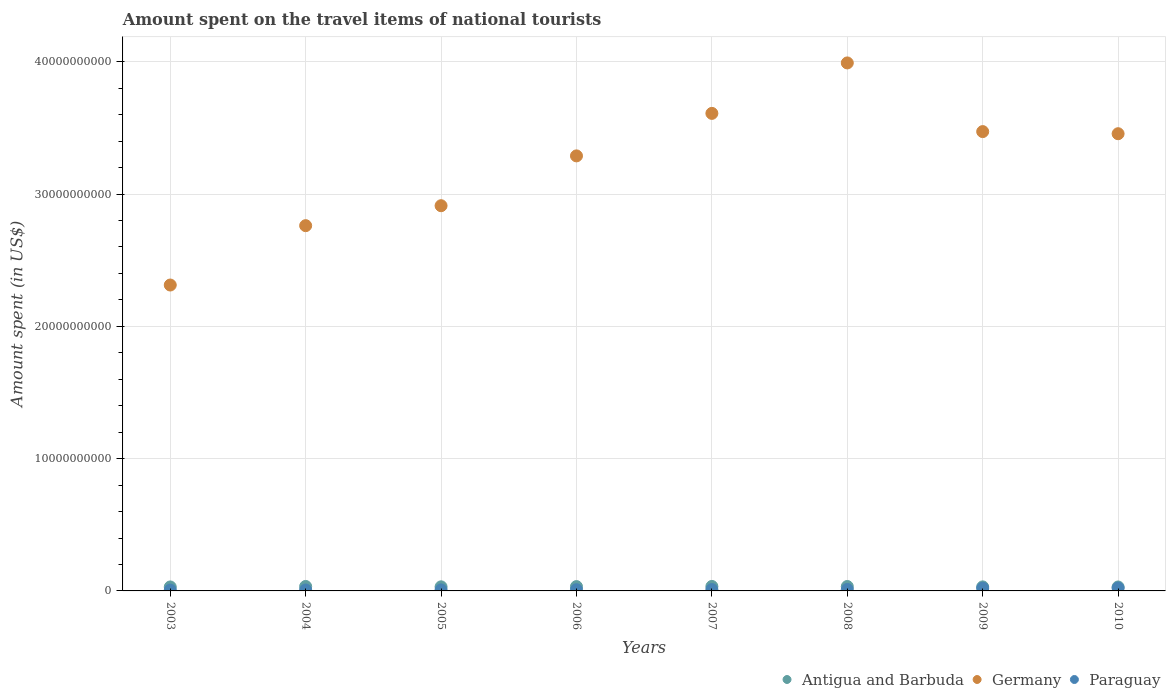Is the number of dotlines equal to the number of legend labels?
Keep it short and to the point. Yes. What is the amount spent on the travel items of national tourists in Paraguay in 2004?
Provide a short and direct response. 7.00e+07. Across all years, what is the maximum amount spent on the travel items of national tourists in Antigua and Barbuda?
Offer a very short reply. 3.38e+08. Across all years, what is the minimum amount spent on the travel items of national tourists in Paraguay?
Give a very brief answer. 6.40e+07. In which year was the amount spent on the travel items of national tourists in Paraguay maximum?
Offer a terse response. 2010. In which year was the amount spent on the travel items of national tourists in Paraguay minimum?
Your response must be concise. 2003. What is the total amount spent on the travel items of national tourists in Germany in the graph?
Provide a succinct answer. 2.58e+11. What is the difference between the amount spent on the travel items of national tourists in Germany in 2005 and that in 2008?
Your answer should be very brief. -1.08e+1. What is the difference between the amount spent on the travel items of national tourists in Germany in 2004 and the amount spent on the travel items of national tourists in Paraguay in 2010?
Provide a short and direct response. 2.74e+1. What is the average amount spent on the travel items of national tourists in Germany per year?
Offer a very short reply. 3.23e+1. In the year 2005, what is the difference between the amount spent on the travel items of national tourists in Antigua and Barbuda and amount spent on the travel items of national tourists in Germany?
Your response must be concise. -2.88e+1. What is the ratio of the amount spent on the travel items of national tourists in Germany in 2006 to that in 2010?
Give a very brief answer. 0.95. Is the difference between the amount spent on the travel items of national tourists in Antigua and Barbuda in 2003 and 2009 greater than the difference between the amount spent on the travel items of national tourists in Germany in 2003 and 2009?
Your response must be concise. Yes. What is the difference between the highest and the second highest amount spent on the travel items of national tourists in Antigua and Barbuda?
Provide a short and direct response. 1.00e+06. What is the difference between the highest and the lowest amount spent on the travel items of national tourists in Antigua and Barbuda?
Offer a very short reply. 4.00e+07. In how many years, is the amount spent on the travel items of national tourists in Paraguay greater than the average amount spent on the travel items of national tourists in Paraguay taken over all years?
Your answer should be compact. 2. Is the sum of the amount spent on the travel items of national tourists in Germany in 2006 and 2010 greater than the maximum amount spent on the travel items of national tourists in Paraguay across all years?
Your answer should be compact. Yes. Does the amount spent on the travel items of national tourists in Germany monotonically increase over the years?
Offer a terse response. No. Is the amount spent on the travel items of national tourists in Paraguay strictly less than the amount spent on the travel items of national tourists in Germany over the years?
Provide a short and direct response. Yes. How many dotlines are there?
Your answer should be very brief. 3. What is the difference between two consecutive major ticks on the Y-axis?
Keep it short and to the point. 1.00e+1. Are the values on the major ticks of Y-axis written in scientific E-notation?
Give a very brief answer. No. Does the graph contain grids?
Give a very brief answer. Yes. Where does the legend appear in the graph?
Give a very brief answer. Bottom right. What is the title of the graph?
Offer a very short reply. Amount spent on the travel items of national tourists. What is the label or title of the Y-axis?
Offer a terse response. Amount spent (in US$). What is the Amount spent (in US$) in Antigua and Barbuda in 2003?
Keep it short and to the point. 3.00e+08. What is the Amount spent (in US$) of Germany in 2003?
Provide a short and direct response. 2.31e+1. What is the Amount spent (in US$) of Paraguay in 2003?
Offer a very short reply. 6.40e+07. What is the Amount spent (in US$) in Antigua and Barbuda in 2004?
Your answer should be compact. 3.37e+08. What is the Amount spent (in US$) in Germany in 2004?
Give a very brief answer. 2.76e+1. What is the Amount spent (in US$) of Paraguay in 2004?
Provide a succinct answer. 7.00e+07. What is the Amount spent (in US$) in Antigua and Barbuda in 2005?
Provide a short and direct response. 3.09e+08. What is the Amount spent (in US$) of Germany in 2005?
Keep it short and to the point. 2.91e+1. What is the Amount spent (in US$) of Paraguay in 2005?
Provide a succinct answer. 7.80e+07. What is the Amount spent (in US$) of Antigua and Barbuda in 2006?
Provide a short and direct response. 3.27e+08. What is the Amount spent (in US$) of Germany in 2006?
Your answer should be compact. 3.29e+1. What is the Amount spent (in US$) of Paraguay in 2006?
Your answer should be very brief. 9.20e+07. What is the Amount spent (in US$) in Antigua and Barbuda in 2007?
Your answer should be very brief. 3.38e+08. What is the Amount spent (in US$) of Germany in 2007?
Offer a very short reply. 3.61e+1. What is the Amount spent (in US$) of Paraguay in 2007?
Keep it short and to the point. 1.02e+08. What is the Amount spent (in US$) of Antigua and Barbuda in 2008?
Offer a terse response. 3.34e+08. What is the Amount spent (in US$) of Germany in 2008?
Your response must be concise. 3.99e+1. What is the Amount spent (in US$) of Paraguay in 2008?
Give a very brief answer. 1.09e+08. What is the Amount spent (in US$) in Antigua and Barbuda in 2009?
Provide a succinct answer. 3.05e+08. What is the Amount spent (in US$) in Germany in 2009?
Provide a succinct answer. 3.47e+1. What is the Amount spent (in US$) in Paraguay in 2009?
Offer a terse response. 2.05e+08. What is the Amount spent (in US$) of Antigua and Barbuda in 2010?
Provide a succinct answer. 2.98e+08. What is the Amount spent (in US$) of Germany in 2010?
Keep it short and to the point. 3.46e+1. What is the Amount spent (in US$) of Paraguay in 2010?
Provide a short and direct response. 2.17e+08. Across all years, what is the maximum Amount spent (in US$) of Antigua and Barbuda?
Provide a succinct answer. 3.38e+08. Across all years, what is the maximum Amount spent (in US$) in Germany?
Your response must be concise. 3.99e+1. Across all years, what is the maximum Amount spent (in US$) of Paraguay?
Offer a terse response. 2.17e+08. Across all years, what is the minimum Amount spent (in US$) in Antigua and Barbuda?
Ensure brevity in your answer.  2.98e+08. Across all years, what is the minimum Amount spent (in US$) of Germany?
Give a very brief answer. 2.31e+1. Across all years, what is the minimum Amount spent (in US$) in Paraguay?
Your answer should be very brief. 6.40e+07. What is the total Amount spent (in US$) in Antigua and Barbuda in the graph?
Offer a terse response. 2.55e+09. What is the total Amount spent (in US$) of Germany in the graph?
Ensure brevity in your answer.  2.58e+11. What is the total Amount spent (in US$) in Paraguay in the graph?
Offer a terse response. 9.37e+08. What is the difference between the Amount spent (in US$) in Antigua and Barbuda in 2003 and that in 2004?
Offer a very short reply. -3.70e+07. What is the difference between the Amount spent (in US$) in Germany in 2003 and that in 2004?
Keep it short and to the point. -4.49e+09. What is the difference between the Amount spent (in US$) of Paraguay in 2003 and that in 2004?
Your answer should be compact. -6.00e+06. What is the difference between the Amount spent (in US$) of Antigua and Barbuda in 2003 and that in 2005?
Your response must be concise. -9.00e+06. What is the difference between the Amount spent (in US$) in Germany in 2003 and that in 2005?
Provide a short and direct response. -6.00e+09. What is the difference between the Amount spent (in US$) of Paraguay in 2003 and that in 2005?
Your answer should be very brief. -1.40e+07. What is the difference between the Amount spent (in US$) of Antigua and Barbuda in 2003 and that in 2006?
Keep it short and to the point. -2.70e+07. What is the difference between the Amount spent (in US$) in Germany in 2003 and that in 2006?
Give a very brief answer. -9.76e+09. What is the difference between the Amount spent (in US$) in Paraguay in 2003 and that in 2006?
Offer a terse response. -2.80e+07. What is the difference between the Amount spent (in US$) of Antigua and Barbuda in 2003 and that in 2007?
Provide a short and direct response. -3.80e+07. What is the difference between the Amount spent (in US$) in Germany in 2003 and that in 2007?
Ensure brevity in your answer.  -1.30e+1. What is the difference between the Amount spent (in US$) in Paraguay in 2003 and that in 2007?
Your answer should be very brief. -3.80e+07. What is the difference between the Amount spent (in US$) in Antigua and Barbuda in 2003 and that in 2008?
Your response must be concise. -3.40e+07. What is the difference between the Amount spent (in US$) of Germany in 2003 and that in 2008?
Provide a succinct answer. -1.68e+1. What is the difference between the Amount spent (in US$) in Paraguay in 2003 and that in 2008?
Provide a short and direct response. -4.50e+07. What is the difference between the Amount spent (in US$) in Antigua and Barbuda in 2003 and that in 2009?
Your answer should be very brief. -5.00e+06. What is the difference between the Amount spent (in US$) of Germany in 2003 and that in 2009?
Provide a succinct answer. -1.16e+1. What is the difference between the Amount spent (in US$) in Paraguay in 2003 and that in 2009?
Keep it short and to the point. -1.41e+08. What is the difference between the Amount spent (in US$) of Germany in 2003 and that in 2010?
Ensure brevity in your answer.  -1.14e+1. What is the difference between the Amount spent (in US$) in Paraguay in 2003 and that in 2010?
Your response must be concise. -1.53e+08. What is the difference between the Amount spent (in US$) in Antigua and Barbuda in 2004 and that in 2005?
Offer a terse response. 2.80e+07. What is the difference between the Amount spent (in US$) of Germany in 2004 and that in 2005?
Your answer should be compact. -1.51e+09. What is the difference between the Amount spent (in US$) of Paraguay in 2004 and that in 2005?
Your response must be concise. -8.00e+06. What is the difference between the Amount spent (in US$) in Antigua and Barbuda in 2004 and that in 2006?
Your answer should be very brief. 1.00e+07. What is the difference between the Amount spent (in US$) in Germany in 2004 and that in 2006?
Provide a short and direct response. -5.28e+09. What is the difference between the Amount spent (in US$) in Paraguay in 2004 and that in 2006?
Ensure brevity in your answer.  -2.20e+07. What is the difference between the Amount spent (in US$) in Germany in 2004 and that in 2007?
Keep it short and to the point. -8.49e+09. What is the difference between the Amount spent (in US$) in Paraguay in 2004 and that in 2007?
Your response must be concise. -3.20e+07. What is the difference between the Amount spent (in US$) of Antigua and Barbuda in 2004 and that in 2008?
Provide a short and direct response. 3.00e+06. What is the difference between the Amount spent (in US$) in Germany in 2004 and that in 2008?
Make the answer very short. -1.23e+1. What is the difference between the Amount spent (in US$) of Paraguay in 2004 and that in 2008?
Offer a terse response. -3.90e+07. What is the difference between the Amount spent (in US$) in Antigua and Barbuda in 2004 and that in 2009?
Keep it short and to the point. 3.20e+07. What is the difference between the Amount spent (in US$) in Germany in 2004 and that in 2009?
Keep it short and to the point. -7.11e+09. What is the difference between the Amount spent (in US$) of Paraguay in 2004 and that in 2009?
Offer a terse response. -1.35e+08. What is the difference between the Amount spent (in US$) in Antigua and Barbuda in 2004 and that in 2010?
Make the answer very short. 3.90e+07. What is the difference between the Amount spent (in US$) of Germany in 2004 and that in 2010?
Give a very brief answer. -6.95e+09. What is the difference between the Amount spent (in US$) in Paraguay in 2004 and that in 2010?
Your answer should be very brief. -1.47e+08. What is the difference between the Amount spent (in US$) of Antigua and Barbuda in 2005 and that in 2006?
Provide a short and direct response. -1.80e+07. What is the difference between the Amount spent (in US$) of Germany in 2005 and that in 2006?
Make the answer very short. -3.77e+09. What is the difference between the Amount spent (in US$) of Paraguay in 2005 and that in 2006?
Your answer should be very brief. -1.40e+07. What is the difference between the Amount spent (in US$) in Antigua and Barbuda in 2005 and that in 2007?
Provide a succinct answer. -2.90e+07. What is the difference between the Amount spent (in US$) in Germany in 2005 and that in 2007?
Offer a very short reply. -6.98e+09. What is the difference between the Amount spent (in US$) in Paraguay in 2005 and that in 2007?
Your response must be concise. -2.40e+07. What is the difference between the Amount spent (in US$) in Antigua and Barbuda in 2005 and that in 2008?
Your answer should be very brief. -2.50e+07. What is the difference between the Amount spent (in US$) of Germany in 2005 and that in 2008?
Offer a very short reply. -1.08e+1. What is the difference between the Amount spent (in US$) in Paraguay in 2005 and that in 2008?
Offer a very short reply. -3.10e+07. What is the difference between the Amount spent (in US$) in Germany in 2005 and that in 2009?
Keep it short and to the point. -5.60e+09. What is the difference between the Amount spent (in US$) of Paraguay in 2005 and that in 2009?
Ensure brevity in your answer.  -1.27e+08. What is the difference between the Amount spent (in US$) in Antigua and Barbuda in 2005 and that in 2010?
Your answer should be compact. 1.10e+07. What is the difference between the Amount spent (in US$) in Germany in 2005 and that in 2010?
Your answer should be very brief. -5.44e+09. What is the difference between the Amount spent (in US$) in Paraguay in 2005 and that in 2010?
Provide a short and direct response. -1.39e+08. What is the difference between the Amount spent (in US$) of Antigua and Barbuda in 2006 and that in 2007?
Your response must be concise. -1.10e+07. What is the difference between the Amount spent (in US$) in Germany in 2006 and that in 2007?
Provide a succinct answer. -3.21e+09. What is the difference between the Amount spent (in US$) in Paraguay in 2006 and that in 2007?
Keep it short and to the point. -1.00e+07. What is the difference between the Amount spent (in US$) of Antigua and Barbuda in 2006 and that in 2008?
Your response must be concise. -7.00e+06. What is the difference between the Amount spent (in US$) of Germany in 2006 and that in 2008?
Offer a terse response. -7.03e+09. What is the difference between the Amount spent (in US$) in Paraguay in 2006 and that in 2008?
Ensure brevity in your answer.  -1.70e+07. What is the difference between the Amount spent (in US$) in Antigua and Barbuda in 2006 and that in 2009?
Make the answer very short. 2.20e+07. What is the difference between the Amount spent (in US$) in Germany in 2006 and that in 2009?
Provide a short and direct response. -1.84e+09. What is the difference between the Amount spent (in US$) of Paraguay in 2006 and that in 2009?
Give a very brief answer. -1.13e+08. What is the difference between the Amount spent (in US$) in Antigua and Barbuda in 2006 and that in 2010?
Your answer should be very brief. 2.90e+07. What is the difference between the Amount spent (in US$) of Germany in 2006 and that in 2010?
Provide a short and direct response. -1.68e+09. What is the difference between the Amount spent (in US$) of Paraguay in 2006 and that in 2010?
Provide a short and direct response. -1.25e+08. What is the difference between the Amount spent (in US$) in Germany in 2007 and that in 2008?
Provide a short and direct response. -3.81e+09. What is the difference between the Amount spent (in US$) in Paraguay in 2007 and that in 2008?
Make the answer very short. -7.00e+06. What is the difference between the Amount spent (in US$) in Antigua and Barbuda in 2007 and that in 2009?
Keep it short and to the point. 3.30e+07. What is the difference between the Amount spent (in US$) in Germany in 2007 and that in 2009?
Give a very brief answer. 1.38e+09. What is the difference between the Amount spent (in US$) of Paraguay in 2007 and that in 2009?
Give a very brief answer. -1.03e+08. What is the difference between the Amount spent (in US$) of Antigua and Barbuda in 2007 and that in 2010?
Offer a very short reply. 4.00e+07. What is the difference between the Amount spent (in US$) of Germany in 2007 and that in 2010?
Your response must be concise. 1.54e+09. What is the difference between the Amount spent (in US$) of Paraguay in 2007 and that in 2010?
Keep it short and to the point. -1.15e+08. What is the difference between the Amount spent (in US$) of Antigua and Barbuda in 2008 and that in 2009?
Keep it short and to the point. 2.90e+07. What is the difference between the Amount spent (in US$) in Germany in 2008 and that in 2009?
Offer a terse response. 5.19e+09. What is the difference between the Amount spent (in US$) of Paraguay in 2008 and that in 2009?
Offer a terse response. -9.60e+07. What is the difference between the Amount spent (in US$) of Antigua and Barbuda in 2008 and that in 2010?
Make the answer very short. 3.60e+07. What is the difference between the Amount spent (in US$) of Germany in 2008 and that in 2010?
Ensure brevity in your answer.  5.35e+09. What is the difference between the Amount spent (in US$) in Paraguay in 2008 and that in 2010?
Give a very brief answer. -1.08e+08. What is the difference between the Amount spent (in US$) in Germany in 2009 and that in 2010?
Make the answer very short. 1.60e+08. What is the difference between the Amount spent (in US$) in Paraguay in 2009 and that in 2010?
Make the answer very short. -1.20e+07. What is the difference between the Amount spent (in US$) in Antigua and Barbuda in 2003 and the Amount spent (in US$) in Germany in 2004?
Give a very brief answer. -2.73e+1. What is the difference between the Amount spent (in US$) of Antigua and Barbuda in 2003 and the Amount spent (in US$) of Paraguay in 2004?
Offer a terse response. 2.30e+08. What is the difference between the Amount spent (in US$) of Germany in 2003 and the Amount spent (in US$) of Paraguay in 2004?
Provide a short and direct response. 2.31e+1. What is the difference between the Amount spent (in US$) of Antigua and Barbuda in 2003 and the Amount spent (in US$) of Germany in 2005?
Provide a succinct answer. -2.88e+1. What is the difference between the Amount spent (in US$) of Antigua and Barbuda in 2003 and the Amount spent (in US$) of Paraguay in 2005?
Offer a very short reply. 2.22e+08. What is the difference between the Amount spent (in US$) in Germany in 2003 and the Amount spent (in US$) in Paraguay in 2005?
Your answer should be very brief. 2.30e+1. What is the difference between the Amount spent (in US$) of Antigua and Barbuda in 2003 and the Amount spent (in US$) of Germany in 2006?
Your response must be concise. -3.26e+1. What is the difference between the Amount spent (in US$) of Antigua and Barbuda in 2003 and the Amount spent (in US$) of Paraguay in 2006?
Your response must be concise. 2.08e+08. What is the difference between the Amount spent (in US$) of Germany in 2003 and the Amount spent (in US$) of Paraguay in 2006?
Offer a terse response. 2.30e+1. What is the difference between the Amount spent (in US$) of Antigua and Barbuda in 2003 and the Amount spent (in US$) of Germany in 2007?
Offer a very short reply. -3.58e+1. What is the difference between the Amount spent (in US$) of Antigua and Barbuda in 2003 and the Amount spent (in US$) of Paraguay in 2007?
Your response must be concise. 1.98e+08. What is the difference between the Amount spent (in US$) in Germany in 2003 and the Amount spent (in US$) in Paraguay in 2007?
Offer a terse response. 2.30e+1. What is the difference between the Amount spent (in US$) in Antigua and Barbuda in 2003 and the Amount spent (in US$) in Germany in 2008?
Your response must be concise. -3.96e+1. What is the difference between the Amount spent (in US$) of Antigua and Barbuda in 2003 and the Amount spent (in US$) of Paraguay in 2008?
Your response must be concise. 1.91e+08. What is the difference between the Amount spent (in US$) in Germany in 2003 and the Amount spent (in US$) in Paraguay in 2008?
Your response must be concise. 2.30e+1. What is the difference between the Amount spent (in US$) in Antigua and Barbuda in 2003 and the Amount spent (in US$) in Germany in 2009?
Give a very brief answer. -3.44e+1. What is the difference between the Amount spent (in US$) of Antigua and Barbuda in 2003 and the Amount spent (in US$) of Paraguay in 2009?
Ensure brevity in your answer.  9.50e+07. What is the difference between the Amount spent (in US$) in Germany in 2003 and the Amount spent (in US$) in Paraguay in 2009?
Offer a terse response. 2.29e+1. What is the difference between the Amount spent (in US$) of Antigua and Barbuda in 2003 and the Amount spent (in US$) of Germany in 2010?
Your response must be concise. -3.43e+1. What is the difference between the Amount spent (in US$) in Antigua and Barbuda in 2003 and the Amount spent (in US$) in Paraguay in 2010?
Give a very brief answer. 8.30e+07. What is the difference between the Amount spent (in US$) in Germany in 2003 and the Amount spent (in US$) in Paraguay in 2010?
Your answer should be compact. 2.29e+1. What is the difference between the Amount spent (in US$) of Antigua and Barbuda in 2004 and the Amount spent (in US$) of Germany in 2005?
Provide a short and direct response. -2.88e+1. What is the difference between the Amount spent (in US$) in Antigua and Barbuda in 2004 and the Amount spent (in US$) in Paraguay in 2005?
Make the answer very short. 2.59e+08. What is the difference between the Amount spent (in US$) in Germany in 2004 and the Amount spent (in US$) in Paraguay in 2005?
Provide a short and direct response. 2.75e+1. What is the difference between the Amount spent (in US$) in Antigua and Barbuda in 2004 and the Amount spent (in US$) in Germany in 2006?
Offer a very short reply. -3.26e+1. What is the difference between the Amount spent (in US$) of Antigua and Barbuda in 2004 and the Amount spent (in US$) of Paraguay in 2006?
Your response must be concise. 2.45e+08. What is the difference between the Amount spent (in US$) in Germany in 2004 and the Amount spent (in US$) in Paraguay in 2006?
Ensure brevity in your answer.  2.75e+1. What is the difference between the Amount spent (in US$) of Antigua and Barbuda in 2004 and the Amount spent (in US$) of Germany in 2007?
Your answer should be compact. -3.58e+1. What is the difference between the Amount spent (in US$) in Antigua and Barbuda in 2004 and the Amount spent (in US$) in Paraguay in 2007?
Keep it short and to the point. 2.35e+08. What is the difference between the Amount spent (in US$) in Germany in 2004 and the Amount spent (in US$) in Paraguay in 2007?
Your answer should be very brief. 2.75e+1. What is the difference between the Amount spent (in US$) in Antigua and Barbuda in 2004 and the Amount spent (in US$) in Germany in 2008?
Keep it short and to the point. -3.96e+1. What is the difference between the Amount spent (in US$) in Antigua and Barbuda in 2004 and the Amount spent (in US$) in Paraguay in 2008?
Your response must be concise. 2.28e+08. What is the difference between the Amount spent (in US$) in Germany in 2004 and the Amount spent (in US$) in Paraguay in 2008?
Offer a very short reply. 2.75e+1. What is the difference between the Amount spent (in US$) of Antigua and Barbuda in 2004 and the Amount spent (in US$) of Germany in 2009?
Your answer should be compact. -3.44e+1. What is the difference between the Amount spent (in US$) in Antigua and Barbuda in 2004 and the Amount spent (in US$) in Paraguay in 2009?
Make the answer very short. 1.32e+08. What is the difference between the Amount spent (in US$) in Germany in 2004 and the Amount spent (in US$) in Paraguay in 2009?
Your response must be concise. 2.74e+1. What is the difference between the Amount spent (in US$) in Antigua and Barbuda in 2004 and the Amount spent (in US$) in Germany in 2010?
Offer a very short reply. -3.42e+1. What is the difference between the Amount spent (in US$) of Antigua and Barbuda in 2004 and the Amount spent (in US$) of Paraguay in 2010?
Give a very brief answer. 1.20e+08. What is the difference between the Amount spent (in US$) in Germany in 2004 and the Amount spent (in US$) in Paraguay in 2010?
Provide a short and direct response. 2.74e+1. What is the difference between the Amount spent (in US$) in Antigua and Barbuda in 2005 and the Amount spent (in US$) in Germany in 2006?
Make the answer very short. -3.26e+1. What is the difference between the Amount spent (in US$) of Antigua and Barbuda in 2005 and the Amount spent (in US$) of Paraguay in 2006?
Give a very brief answer. 2.17e+08. What is the difference between the Amount spent (in US$) in Germany in 2005 and the Amount spent (in US$) in Paraguay in 2006?
Give a very brief answer. 2.90e+1. What is the difference between the Amount spent (in US$) of Antigua and Barbuda in 2005 and the Amount spent (in US$) of Germany in 2007?
Offer a very short reply. -3.58e+1. What is the difference between the Amount spent (in US$) in Antigua and Barbuda in 2005 and the Amount spent (in US$) in Paraguay in 2007?
Your answer should be very brief. 2.07e+08. What is the difference between the Amount spent (in US$) of Germany in 2005 and the Amount spent (in US$) of Paraguay in 2007?
Your answer should be compact. 2.90e+1. What is the difference between the Amount spent (in US$) in Antigua and Barbuda in 2005 and the Amount spent (in US$) in Germany in 2008?
Ensure brevity in your answer.  -3.96e+1. What is the difference between the Amount spent (in US$) in Antigua and Barbuda in 2005 and the Amount spent (in US$) in Paraguay in 2008?
Your answer should be compact. 2.00e+08. What is the difference between the Amount spent (in US$) in Germany in 2005 and the Amount spent (in US$) in Paraguay in 2008?
Keep it short and to the point. 2.90e+1. What is the difference between the Amount spent (in US$) of Antigua and Barbuda in 2005 and the Amount spent (in US$) of Germany in 2009?
Give a very brief answer. -3.44e+1. What is the difference between the Amount spent (in US$) of Antigua and Barbuda in 2005 and the Amount spent (in US$) of Paraguay in 2009?
Give a very brief answer. 1.04e+08. What is the difference between the Amount spent (in US$) of Germany in 2005 and the Amount spent (in US$) of Paraguay in 2009?
Ensure brevity in your answer.  2.89e+1. What is the difference between the Amount spent (in US$) of Antigua and Barbuda in 2005 and the Amount spent (in US$) of Germany in 2010?
Offer a terse response. -3.43e+1. What is the difference between the Amount spent (in US$) in Antigua and Barbuda in 2005 and the Amount spent (in US$) in Paraguay in 2010?
Provide a short and direct response. 9.20e+07. What is the difference between the Amount spent (in US$) in Germany in 2005 and the Amount spent (in US$) in Paraguay in 2010?
Provide a succinct answer. 2.89e+1. What is the difference between the Amount spent (in US$) of Antigua and Barbuda in 2006 and the Amount spent (in US$) of Germany in 2007?
Offer a terse response. -3.58e+1. What is the difference between the Amount spent (in US$) of Antigua and Barbuda in 2006 and the Amount spent (in US$) of Paraguay in 2007?
Give a very brief answer. 2.25e+08. What is the difference between the Amount spent (in US$) of Germany in 2006 and the Amount spent (in US$) of Paraguay in 2007?
Offer a very short reply. 3.28e+1. What is the difference between the Amount spent (in US$) of Antigua and Barbuda in 2006 and the Amount spent (in US$) of Germany in 2008?
Your answer should be compact. -3.96e+1. What is the difference between the Amount spent (in US$) of Antigua and Barbuda in 2006 and the Amount spent (in US$) of Paraguay in 2008?
Ensure brevity in your answer.  2.18e+08. What is the difference between the Amount spent (in US$) in Germany in 2006 and the Amount spent (in US$) in Paraguay in 2008?
Offer a very short reply. 3.28e+1. What is the difference between the Amount spent (in US$) in Antigua and Barbuda in 2006 and the Amount spent (in US$) in Germany in 2009?
Give a very brief answer. -3.44e+1. What is the difference between the Amount spent (in US$) of Antigua and Barbuda in 2006 and the Amount spent (in US$) of Paraguay in 2009?
Your response must be concise. 1.22e+08. What is the difference between the Amount spent (in US$) in Germany in 2006 and the Amount spent (in US$) in Paraguay in 2009?
Keep it short and to the point. 3.27e+1. What is the difference between the Amount spent (in US$) of Antigua and Barbuda in 2006 and the Amount spent (in US$) of Germany in 2010?
Give a very brief answer. -3.42e+1. What is the difference between the Amount spent (in US$) in Antigua and Barbuda in 2006 and the Amount spent (in US$) in Paraguay in 2010?
Make the answer very short. 1.10e+08. What is the difference between the Amount spent (in US$) of Germany in 2006 and the Amount spent (in US$) of Paraguay in 2010?
Your answer should be compact. 3.27e+1. What is the difference between the Amount spent (in US$) of Antigua and Barbuda in 2007 and the Amount spent (in US$) of Germany in 2008?
Your answer should be compact. -3.96e+1. What is the difference between the Amount spent (in US$) in Antigua and Barbuda in 2007 and the Amount spent (in US$) in Paraguay in 2008?
Provide a short and direct response. 2.29e+08. What is the difference between the Amount spent (in US$) of Germany in 2007 and the Amount spent (in US$) of Paraguay in 2008?
Offer a very short reply. 3.60e+1. What is the difference between the Amount spent (in US$) in Antigua and Barbuda in 2007 and the Amount spent (in US$) in Germany in 2009?
Your answer should be very brief. -3.44e+1. What is the difference between the Amount spent (in US$) in Antigua and Barbuda in 2007 and the Amount spent (in US$) in Paraguay in 2009?
Ensure brevity in your answer.  1.33e+08. What is the difference between the Amount spent (in US$) of Germany in 2007 and the Amount spent (in US$) of Paraguay in 2009?
Your answer should be very brief. 3.59e+1. What is the difference between the Amount spent (in US$) in Antigua and Barbuda in 2007 and the Amount spent (in US$) in Germany in 2010?
Your response must be concise. -3.42e+1. What is the difference between the Amount spent (in US$) of Antigua and Barbuda in 2007 and the Amount spent (in US$) of Paraguay in 2010?
Keep it short and to the point. 1.21e+08. What is the difference between the Amount spent (in US$) in Germany in 2007 and the Amount spent (in US$) in Paraguay in 2010?
Offer a very short reply. 3.59e+1. What is the difference between the Amount spent (in US$) in Antigua and Barbuda in 2008 and the Amount spent (in US$) in Germany in 2009?
Provide a succinct answer. -3.44e+1. What is the difference between the Amount spent (in US$) in Antigua and Barbuda in 2008 and the Amount spent (in US$) in Paraguay in 2009?
Make the answer very short. 1.29e+08. What is the difference between the Amount spent (in US$) of Germany in 2008 and the Amount spent (in US$) of Paraguay in 2009?
Keep it short and to the point. 3.97e+1. What is the difference between the Amount spent (in US$) of Antigua and Barbuda in 2008 and the Amount spent (in US$) of Germany in 2010?
Your response must be concise. -3.42e+1. What is the difference between the Amount spent (in US$) of Antigua and Barbuda in 2008 and the Amount spent (in US$) of Paraguay in 2010?
Keep it short and to the point. 1.17e+08. What is the difference between the Amount spent (in US$) in Germany in 2008 and the Amount spent (in US$) in Paraguay in 2010?
Provide a succinct answer. 3.97e+1. What is the difference between the Amount spent (in US$) of Antigua and Barbuda in 2009 and the Amount spent (in US$) of Germany in 2010?
Make the answer very short. -3.43e+1. What is the difference between the Amount spent (in US$) in Antigua and Barbuda in 2009 and the Amount spent (in US$) in Paraguay in 2010?
Your answer should be compact. 8.80e+07. What is the difference between the Amount spent (in US$) in Germany in 2009 and the Amount spent (in US$) in Paraguay in 2010?
Give a very brief answer. 3.45e+1. What is the average Amount spent (in US$) in Antigua and Barbuda per year?
Give a very brief answer. 3.18e+08. What is the average Amount spent (in US$) of Germany per year?
Keep it short and to the point. 3.23e+1. What is the average Amount spent (in US$) of Paraguay per year?
Your answer should be very brief. 1.17e+08. In the year 2003, what is the difference between the Amount spent (in US$) in Antigua and Barbuda and Amount spent (in US$) in Germany?
Offer a terse response. -2.28e+1. In the year 2003, what is the difference between the Amount spent (in US$) of Antigua and Barbuda and Amount spent (in US$) of Paraguay?
Give a very brief answer. 2.36e+08. In the year 2003, what is the difference between the Amount spent (in US$) of Germany and Amount spent (in US$) of Paraguay?
Give a very brief answer. 2.31e+1. In the year 2004, what is the difference between the Amount spent (in US$) in Antigua and Barbuda and Amount spent (in US$) in Germany?
Offer a terse response. -2.73e+1. In the year 2004, what is the difference between the Amount spent (in US$) in Antigua and Barbuda and Amount spent (in US$) in Paraguay?
Your response must be concise. 2.67e+08. In the year 2004, what is the difference between the Amount spent (in US$) in Germany and Amount spent (in US$) in Paraguay?
Ensure brevity in your answer.  2.75e+1. In the year 2005, what is the difference between the Amount spent (in US$) in Antigua and Barbuda and Amount spent (in US$) in Germany?
Your response must be concise. -2.88e+1. In the year 2005, what is the difference between the Amount spent (in US$) of Antigua and Barbuda and Amount spent (in US$) of Paraguay?
Provide a succinct answer. 2.31e+08. In the year 2005, what is the difference between the Amount spent (in US$) of Germany and Amount spent (in US$) of Paraguay?
Your answer should be compact. 2.90e+1. In the year 2006, what is the difference between the Amount spent (in US$) in Antigua and Barbuda and Amount spent (in US$) in Germany?
Your answer should be compact. -3.26e+1. In the year 2006, what is the difference between the Amount spent (in US$) in Antigua and Barbuda and Amount spent (in US$) in Paraguay?
Make the answer very short. 2.35e+08. In the year 2006, what is the difference between the Amount spent (in US$) in Germany and Amount spent (in US$) in Paraguay?
Offer a very short reply. 3.28e+1. In the year 2007, what is the difference between the Amount spent (in US$) of Antigua and Barbuda and Amount spent (in US$) of Germany?
Provide a succinct answer. -3.58e+1. In the year 2007, what is the difference between the Amount spent (in US$) of Antigua and Barbuda and Amount spent (in US$) of Paraguay?
Make the answer very short. 2.36e+08. In the year 2007, what is the difference between the Amount spent (in US$) of Germany and Amount spent (in US$) of Paraguay?
Keep it short and to the point. 3.60e+1. In the year 2008, what is the difference between the Amount spent (in US$) of Antigua and Barbuda and Amount spent (in US$) of Germany?
Provide a short and direct response. -3.96e+1. In the year 2008, what is the difference between the Amount spent (in US$) in Antigua and Barbuda and Amount spent (in US$) in Paraguay?
Offer a terse response. 2.25e+08. In the year 2008, what is the difference between the Amount spent (in US$) of Germany and Amount spent (in US$) of Paraguay?
Your response must be concise. 3.98e+1. In the year 2009, what is the difference between the Amount spent (in US$) of Antigua and Barbuda and Amount spent (in US$) of Germany?
Your answer should be compact. -3.44e+1. In the year 2009, what is the difference between the Amount spent (in US$) in Germany and Amount spent (in US$) in Paraguay?
Offer a terse response. 3.45e+1. In the year 2010, what is the difference between the Amount spent (in US$) in Antigua and Barbuda and Amount spent (in US$) in Germany?
Offer a very short reply. -3.43e+1. In the year 2010, what is the difference between the Amount spent (in US$) in Antigua and Barbuda and Amount spent (in US$) in Paraguay?
Your response must be concise. 8.10e+07. In the year 2010, what is the difference between the Amount spent (in US$) in Germany and Amount spent (in US$) in Paraguay?
Offer a terse response. 3.43e+1. What is the ratio of the Amount spent (in US$) of Antigua and Barbuda in 2003 to that in 2004?
Give a very brief answer. 0.89. What is the ratio of the Amount spent (in US$) in Germany in 2003 to that in 2004?
Make the answer very short. 0.84. What is the ratio of the Amount spent (in US$) in Paraguay in 2003 to that in 2004?
Give a very brief answer. 0.91. What is the ratio of the Amount spent (in US$) in Antigua and Barbuda in 2003 to that in 2005?
Offer a very short reply. 0.97. What is the ratio of the Amount spent (in US$) in Germany in 2003 to that in 2005?
Your answer should be very brief. 0.79. What is the ratio of the Amount spent (in US$) in Paraguay in 2003 to that in 2005?
Provide a succinct answer. 0.82. What is the ratio of the Amount spent (in US$) of Antigua and Barbuda in 2003 to that in 2006?
Your response must be concise. 0.92. What is the ratio of the Amount spent (in US$) of Germany in 2003 to that in 2006?
Your response must be concise. 0.7. What is the ratio of the Amount spent (in US$) in Paraguay in 2003 to that in 2006?
Give a very brief answer. 0.7. What is the ratio of the Amount spent (in US$) of Antigua and Barbuda in 2003 to that in 2007?
Your response must be concise. 0.89. What is the ratio of the Amount spent (in US$) of Germany in 2003 to that in 2007?
Ensure brevity in your answer.  0.64. What is the ratio of the Amount spent (in US$) in Paraguay in 2003 to that in 2007?
Offer a very short reply. 0.63. What is the ratio of the Amount spent (in US$) of Antigua and Barbuda in 2003 to that in 2008?
Your answer should be very brief. 0.9. What is the ratio of the Amount spent (in US$) of Germany in 2003 to that in 2008?
Your response must be concise. 0.58. What is the ratio of the Amount spent (in US$) of Paraguay in 2003 to that in 2008?
Your answer should be compact. 0.59. What is the ratio of the Amount spent (in US$) of Antigua and Barbuda in 2003 to that in 2009?
Ensure brevity in your answer.  0.98. What is the ratio of the Amount spent (in US$) in Germany in 2003 to that in 2009?
Offer a terse response. 0.67. What is the ratio of the Amount spent (in US$) of Paraguay in 2003 to that in 2009?
Make the answer very short. 0.31. What is the ratio of the Amount spent (in US$) of Germany in 2003 to that in 2010?
Keep it short and to the point. 0.67. What is the ratio of the Amount spent (in US$) of Paraguay in 2003 to that in 2010?
Give a very brief answer. 0.29. What is the ratio of the Amount spent (in US$) in Antigua and Barbuda in 2004 to that in 2005?
Ensure brevity in your answer.  1.09. What is the ratio of the Amount spent (in US$) of Germany in 2004 to that in 2005?
Keep it short and to the point. 0.95. What is the ratio of the Amount spent (in US$) in Paraguay in 2004 to that in 2005?
Offer a terse response. 0.9. What is the ratio of the Amount spent (in US$) of Antigua and Barbuda in 2004 to that in 2006?
Make the answer very short. 1.03. What is the ratio of the Amount spent (in US$) of Germany in 2004 to that in 2006?
Ensure brevity in your answer.  0.84. What is the ratio of the Amount spent (in US$) of Paraguay in 2004 to that in 2006?
Provide a short and direct response. 0.76. What is the ratio of the Amount spent (in US$) of Germany in 2004 to that in 2007?
Make the answer very short. 0.76. What is the ratio of the Amount spent (in US$) of Paraguay in 2004 to that in 2007?
Offer a very short reply. 0.69. What is the ratio of the Amount spent (in US$) of Antigua and Barbuda in 2004 to that in 2008?
Give a very brief answer. 1.01. What is the ratio of the Amount spent (in US$) in Germany in 2004 to that in 2008?
Ensure brevity in your answer.  0.69. What is the ratio of the Amount spent (in US$) in Paraguay in 2004 to that in 2008?
Keep it short and to the point. 0.64. What is the ratio of the Amount spent (in US$) in Antigua and Barbuda in 2004 to that in 2009?
Make the answer very short. 1.1. What is the ratio of the Amount spent (in US$) of Germany in 2004 to that in 2009?
Offer a terse response. 0.8. What is the ratio of the Amount spent (in US$) of Paraguay in 2004 to that in 2009?
Ensure brevity in your answer.  0.34. What is the ratio of the Amount spent (in US$) of Antigua and Barbuda in 2004 to that in 2010?
Offer a very short reply. 1.13. What is the ratio of the Amount spent (in US$) in Germany in 2004 to that in 2010?
Ensure brevity in your answer.  0.8. What is the ratio of the Amount spent (in US$) in Paraguay in 2004 to that in 2010?
Offer a terse response. 0.32. What is the ratio of the Amount spent (in US$) of Antigua and Barbuda in 2005 to that in 2006?
Provide a succinct answer. 0.94. What is the ratio of the Amount spent (in US$) of Germany in 2005 to that in 2006?
Keep it short and to the point. 0.89. What is the ratio of the Amount spent (in US$) in Paraguay in 2005 to that in 2006?
Ensure brevity in your answer.  0.85. What is the ratio of the Amount spent (in US$) of Antigua and Barbuda in 2005 to that in 2007?
Offer a terse response. 0.91. What is the ratio of the Amount spent (in US$) in Germany in 2005 to that in 2007?
Your answer should be very brief. 0.81. What is the ratio of the Amount spent (in US$) in Paraguay in 2005 to that in 2007?
Your response must be concise. 0.76. What is the ratio of the Amount spent (in US$) of Antigua and Barbuda in 2005 to that in 2008?
Provide a short and direct response. 0.93. What is the ratio of the Amount spent (in US$) in Germany in 2005 to that in 2008?
Your answer should be very brief. 0.73. What is the ratio of the Amount spent (in US$) in Paraguay in 2005 to that in 2008?
Your answer should be very brief. 0.72. What is the ratio of the Amount spent (in US$) in Antigua and Barbuda in 2005 to that in 2009?
Make the answer very short. 1.01. What is the ratio of the Amount spent (in US$) in Germany in 2005 to that in 2009?
Keep it short and to the point. 0.84. What is the ratio of the Amount spent (in US$) of Paraguay in 2005 to that in 2009?
Keep it short and to the point. 0.38. What is the ratio of the Amount spent (in US$) of Antigua and Barbuda in 2005 to that in 2010?
Your answer should be very brief. 1.04. What is the ratio of the Amount spent (in US$) of Germany in 2005 to that in 2010?
Your answer should be very brief. 0.84. What is the ratio of the Amount spent (in US$) of Paraguay in 2005 to that in 2010?
Your response must be concise. 0.36. What is the ratio of the Amount spent (in US$) in Antigua and Barbuda in 2006 to that in 2007?
Provide a short and direct response. 0.97. What is the ratio of the Amount spent (in US$) in Germany in 2006 to that in 2007?
Give a very brief answer. 0.91. What is the ratio of the Amount spent (in US$) of Paraguay in 2006 to that in 2007?
Your answer should be compact. 0.9. What is the ratio of the Amount spent (in US$) of Germany in 2006 to that in 2008?
Keep it short and to the point. 0.82. What is the ratio of the Amount spent (in US$) of Paraguay in 2006 to that in 2008?
Give a very brief answer. 0.84. What is the ratio of the Amount spent (in US$) in Antigua and Barbuda in 2006 to that in 2009?
Your answer should be compact. 1.07. What is the ratio of the Amount spent (in US$) in Germany in 2006 to that in 2009?
Keep it short and to the point. 0.95. What is the ratio of the Amount spent (in US$) of Paraguay in 2006 to that in 2009?
Your answer should be very brief. 0.45. What is the ratio of the Amount spent (in US$) of Antigua and Barbuda in 2006 to that in 2010?
Your answer should be compact. 1.1. What is the ratio of the Amount spent (in US$) in Germany in 2006 to that in 2010?
Provide a succinct answer. 0.95. What is the ratio of the Amount spent (in US$) in Paraguay in 2006 to that in 2010?
Your answer should be very brief. 0.42. What is the ratio of the Amount spent (in US$) of Germany in 2007 to that in 2008?
Your answer should be very brief. 0.9. What is the ratio of the Amount spent (in US$) in Paraguay in 2007 to that in 2008?
Give a very brief answer. 0.94. What is the ratio of the Amount spent (in US$) in Antigua and Barbuda in 2007 to that in 2009?
Your answer should be compact. 1.11. What is the ratio of the Amount spent (in US$) of Germany in 2007 to that in 2009?
Give a very brief answer. 1.04. What is the ratio of the Amount spent (in US$) in Paraguay in 2007 to that in 2009?
Your answer should be compact. 0.5. What is the ratio of the Amount spent (in US$) in Antigua and Barbuda in 2007 to that in 2010?
Ensure brevity in your answer.  1.13. What is the ratio of the Amount spent (in US$) in Germany in 2007 to that in 2010?
Your answer should be very brief. 1.04. What is the ratio of the Amount spent (in US$) of Paraguay in 2007 to that in 2010?
Offer a very short reply. 0.47. What is the ratio of the Amount spent (in US$) in Antigua and Barbuda in 2008 to that in 2009?
Make the answer very short. 1.1. What is the ratio of the Amount spent (in US$) in Germany in 2008 to that in 2009?
Ensure brevity in your answer.  1.15. What is the ratio of the Amount spent (in US$) in Paraguay in 2008 to that in 2009?
Your response must be concise. 0.53. What is the ratio of the Amount spent (in US$) in Antigua and Barbuda in 2008 to that in 2010?
Provide a short and direct response. 1.12. What is the ratio of the Amount spent (in US$) in Germany in 2008 to that in 2010?
Give a very brief answer. 1.15. What is the ratio of the Amount spent (in US$) in Paraguay in 2008 to that in 2010?
Ensure brevity in your answer.  0.5. What is the ratio of the Amount spent (in US$) in Antigua and Barbuda in 2009 to that in 2010?
Your answer should be very brief. 1.02. What is the ratio of the Amount spent (in US$) in Paraguay in 2009 to that in 2010?
Ensure brevity in your answer.  0.94. What is the difference between the highest and the second highest Amount spent (in US$) in Antigua and Barbuda?
Keep it short and to the point. 1.00e+06. What is the difference between the highest and the second highest Amount spent (in US$) of Germany?
Provide a short and direct response. 3.81e+09. What is the difference between the highest and the second highest Amount spent (in US$) of Paraguay?
Keep it short and to the point. 1.20e+07. What is the difference between the highest and the lowest Amount spent (in US$) of Antigua and Barbuda?
Ensure brevity in your answer.  4.00e+07. What is the difference between the highest and the lowest Amount spent (in US$) of Germany?
Offer a very short reply. 1.68e+1. What is the difference between the highest and the lowest Amount spent (in US$) of Paraguay?
Provide a succinct answer. 1.53e+08. 